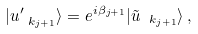<formula> <loc_0><loc_0><loc_500><loc_500>| u ^ { \prime } _ { \ k _ { j + 1 } } \rangle = e ^ { i \beta _ { j + 1 } } | \tilde { u } _ { \ k _ { j + 1 } } \rangle \, ,</formula> 